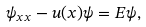Convert formula to latex. <formula><loc_0><loc_0><loc_500><loc_500>\psi _ { x x } - u ( x ) \psi = E \psi ,</formula> 